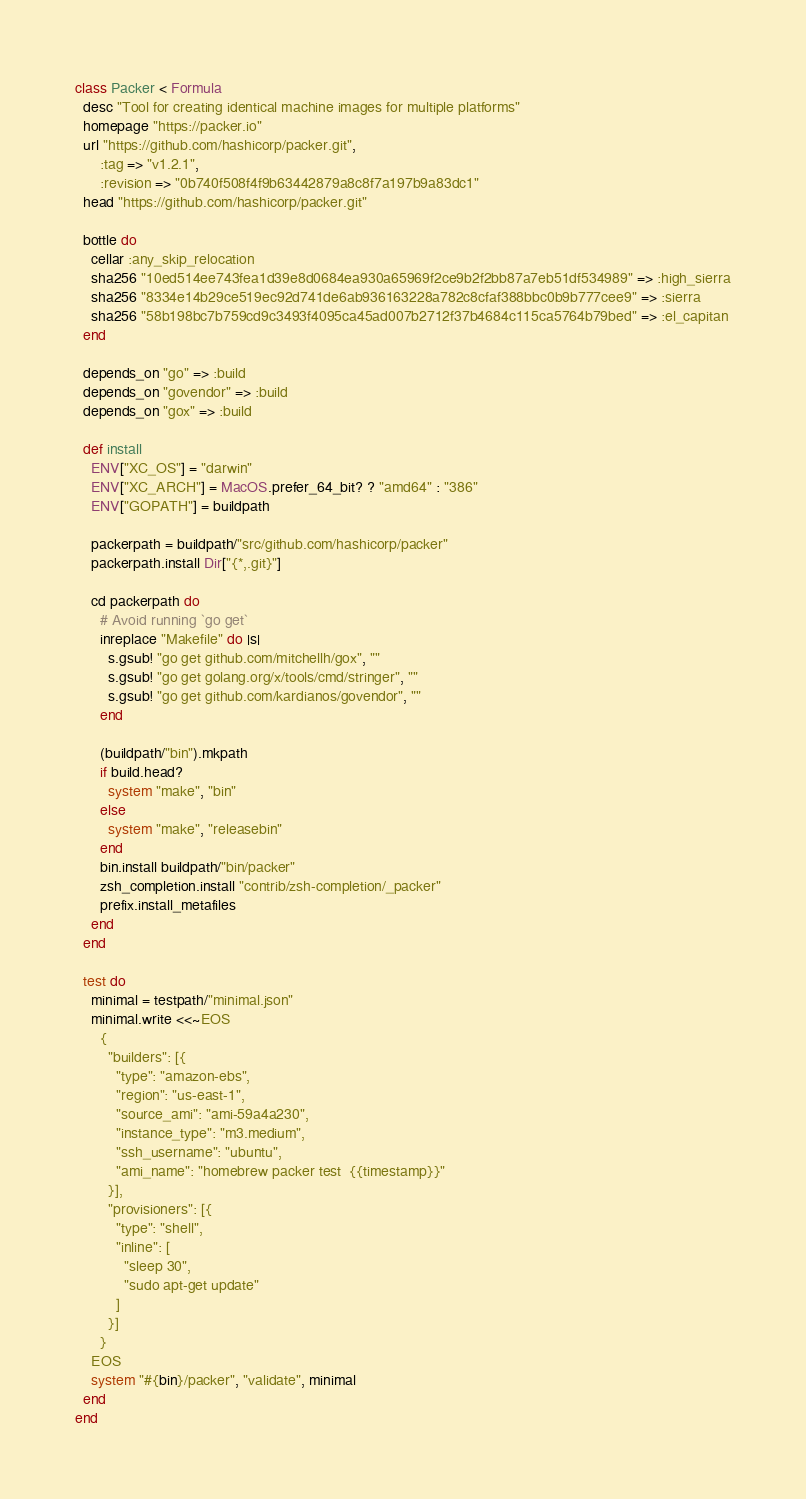<code> <loc_0><loc_0><loc_500><loc_500><_Ruby_>class Packer < Formula
  desc "Tool for creating identical machine images for multiple platforms"
  homepage "https://packer.io"
  url "https://github.com/hashicorp/packer.git",
      :tag => "v1.2.1",
      :revision => "0b740f508f4f9b63442879a8c8f7a197b9a83dc1"
  head "https://github.com/hashicorp/packer.git"

  bottle do
    cellar :any_skip_relocation
    sha256 "10ed514ee743fea1d39e8d0684ea930a65969f2ce9b2f2bb87a7eb51df534989" => :high_sierra
    sha256 "8334e14b29ce519ec92d741de6ab936163228a782c8cfaf388bbc0b9b777cee9" => :sierra
    sha256 "58b198bc7b759cd9c3493f4095ca45ad007b2712f37b4684c115ca5764b79bed" => :el_capitan
  end

  depends_on "go" => :build
  depends_on "govendor" => :build
  depends_on "gox" => :build

  def install
    ENV["XC_OS"] = "darwin"
    ENV["XC_ARCH"] = MacOS.prefer_64_bit? ? "amd64" : "386"
    ENV["GOPATH"] = buildpath

    packerpath = buildpath/"src/github.com/hashicorp/packer"
    packerpath.install Dir["{*,.git}"]

    cd packerpath do
      # Avoid running `go get`
      inreplace "Makefile" do |s|
        s.gsub! "go get github.com/mitchellh/gox", ""
        s.gsub! "go get golang.org/x/tools/cmd/stringer", ""
        s.gsub! "go get github.com/kardianos/govendor", ""
      end

      (buildpath/"bin").mkpath
      if build.head?
        system "make", "bin"
      else
        system "make", "releasebin"
      end
      bin.install buildpath/"bin/packer"
      zsh_completion.install "contrib/zsh-completion/_packer"
      prefix.install_metafiles
    end
  end

  test do
    minimal = testpath/"minimal.json"
    minimal.write <<~EOS
      {
        "builders": [{
          "type": "amazon-ebs",
          "region": "us-east-1",
          "source_ami": "ami-59a4a230",
          "instance_type": "m3.medium",
          "ssh_username": "ubuntu",
          "ami_name": "homebrew packer test  {{timestamp}}"
        }],
        "provisioners": [{
          "type": "shell",
          "inline": [
            "sleep 30",
            "sudo apt-get update"
          ]
        }]
      }
    EOS
    system "#{bin}/packer", "validate", minimal
  end
end
</code> 